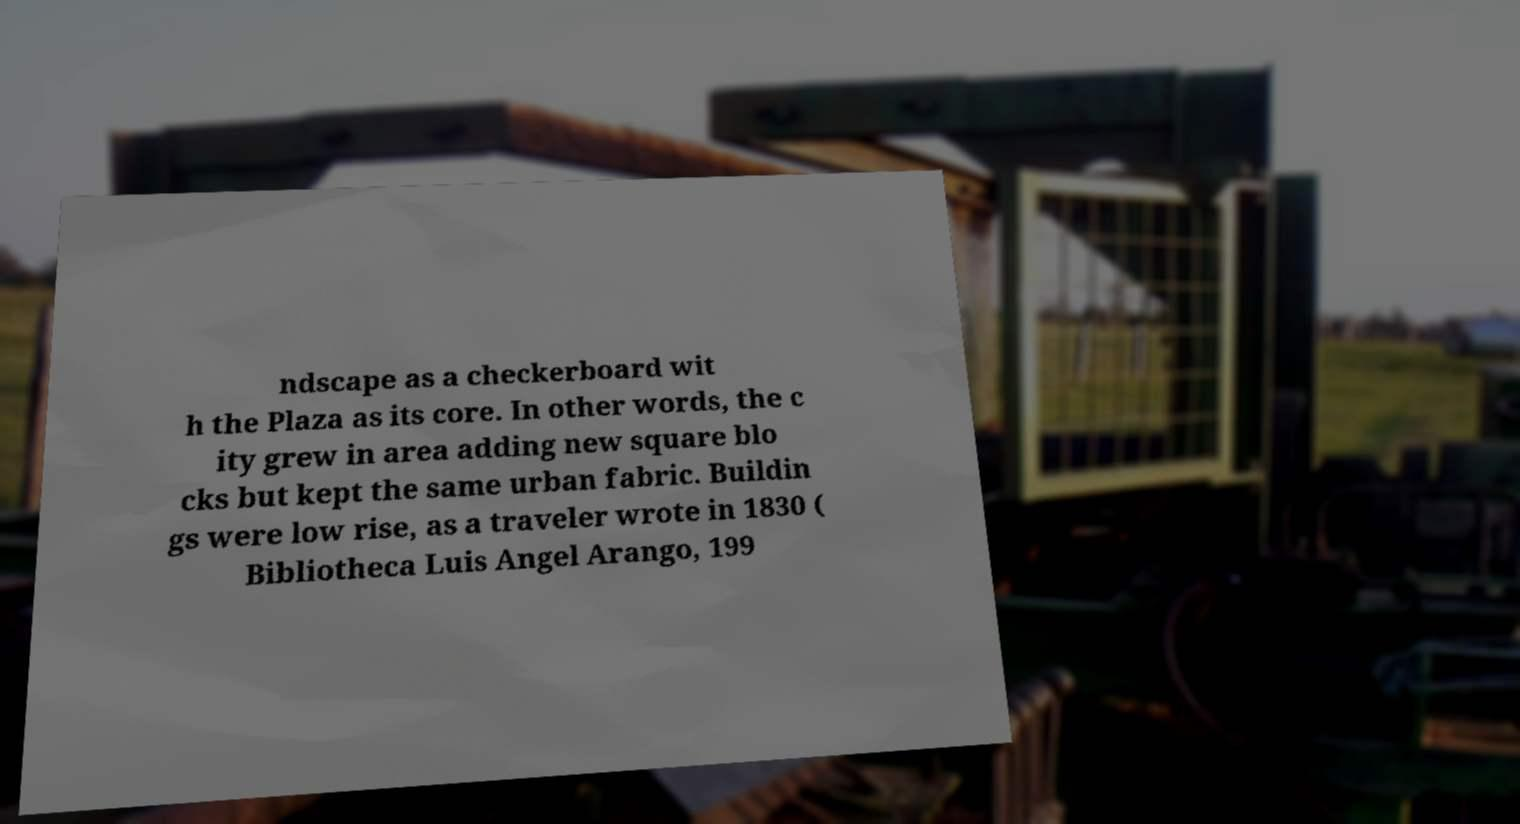Can you read and provide the text displayed in the image?This photo seems to have some interesting text. Can you extract and type it out for me? ndscape as a checkerboard wit h the Plaza as its core. In other words, the c ity grew in area adding new square blo cks but kept the same urban fabric. Buildin gs were low rise, as a traveler wrote in 1830 ( Bibliotheca Luis Angel Arango, 199 